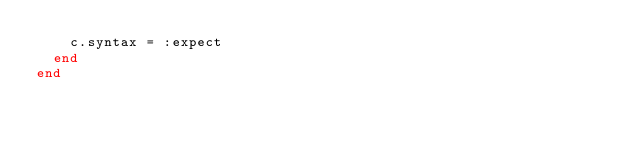Convert code to text. <code><loc_0><loc_0><loc_500><loc_500><_Ruby_>    c.syntax = :expect
  end
end
</code> 